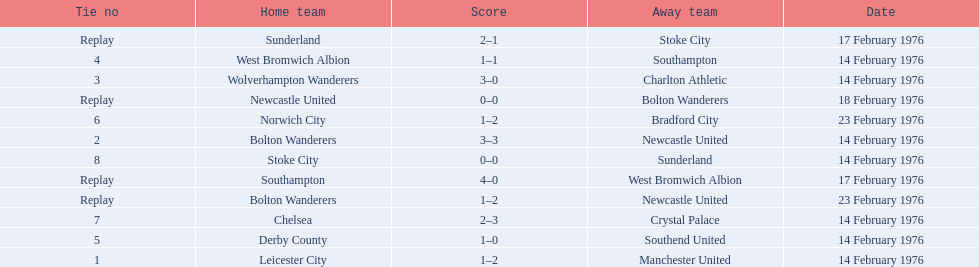What are all of the scores of the 1975-76 fa cup? 1–2, 3–3, 0–0, 1–2, 3–0, 1–1, 4–0, 1–0, 1–2, 2–3, 0–0, 2–1. What are the scores for manchester united or wolverhampton wanderers? 1–2, 3–0. Which has the highest score? 3–0. Who was this score for? Wolverhampton Wanderers. 